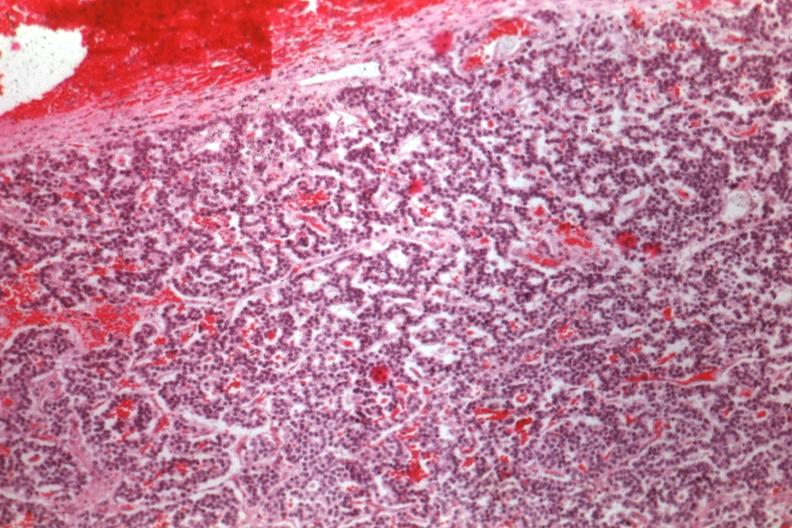s endocrine present?
Answer the question using a single word or phrase. Yes 